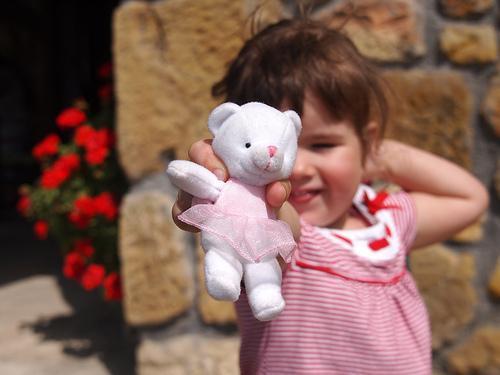How many children are in the photo?
Give a very brief answer. 1. 